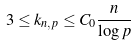<formula> <loc_0><loc_0><loc_500><loc_500>3 \leq k _ { n , p } \leq C _ { 0 } \frac { n } { \log p }</formula> 